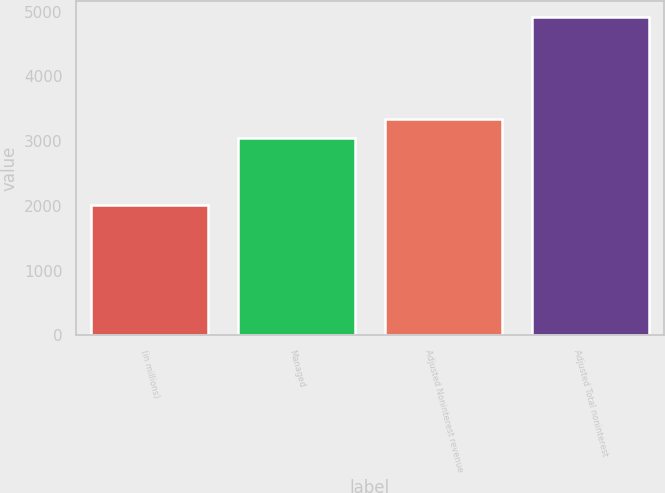Convert chart to OTSL. <chart><loc_0><loc_0><loc_500><loc_500><bar_chart><fcel>(in millions)<fcel>Managed<fcel>Adjusted Noninterest revenue<fcel>Adjusted Total noninterest<nl><fcel>2007<fcel>3046<fcel>3336.7<fcel>4914<nl></chart> 